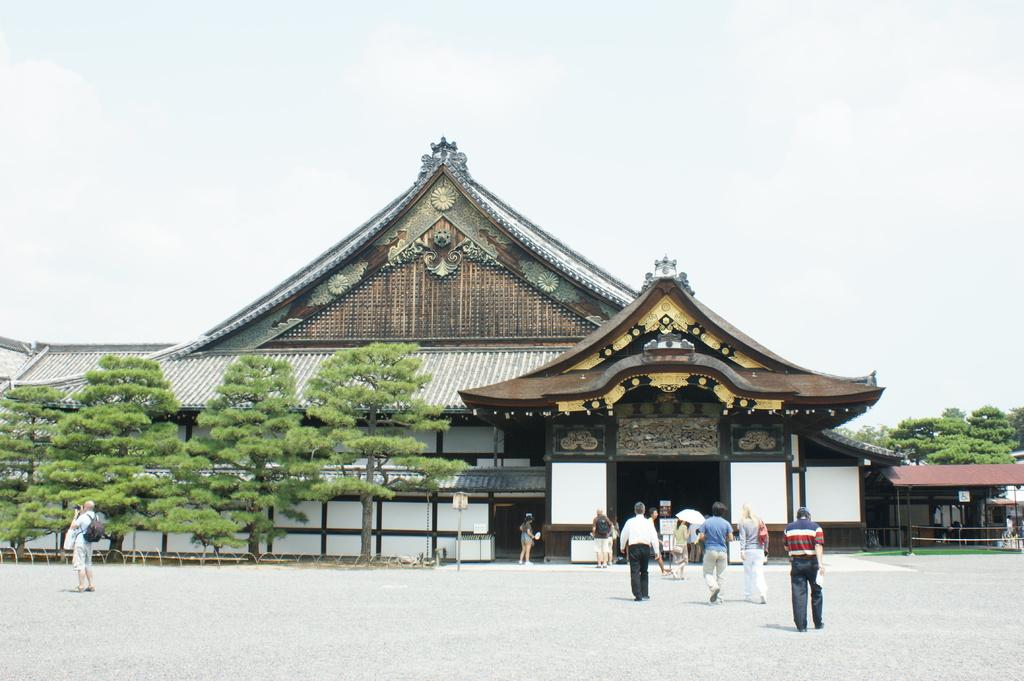How many people are in the image? There are people in the image, but the exact number is not specified. What type of surface is visible in the image? There is ground visible in the image. What objects can be seen in the image that are made of wood? There are boards in the image. What vertical structure is present in the image? There is a pole in the image. What type of shelter is visible in the image? There is a shed in the image. What type of building is visible in the image? There is a house in the image. What type of vegetation is visible in the image? There is grass in the image. What type of tall plants are visible in the image? There are trees in the image. What can be seen in the background of the image? The sky is visible in the background of the image. How many babies are crawling on the roof of the house in the image? There are no babies present in the image, and there is no mention of a roof. 